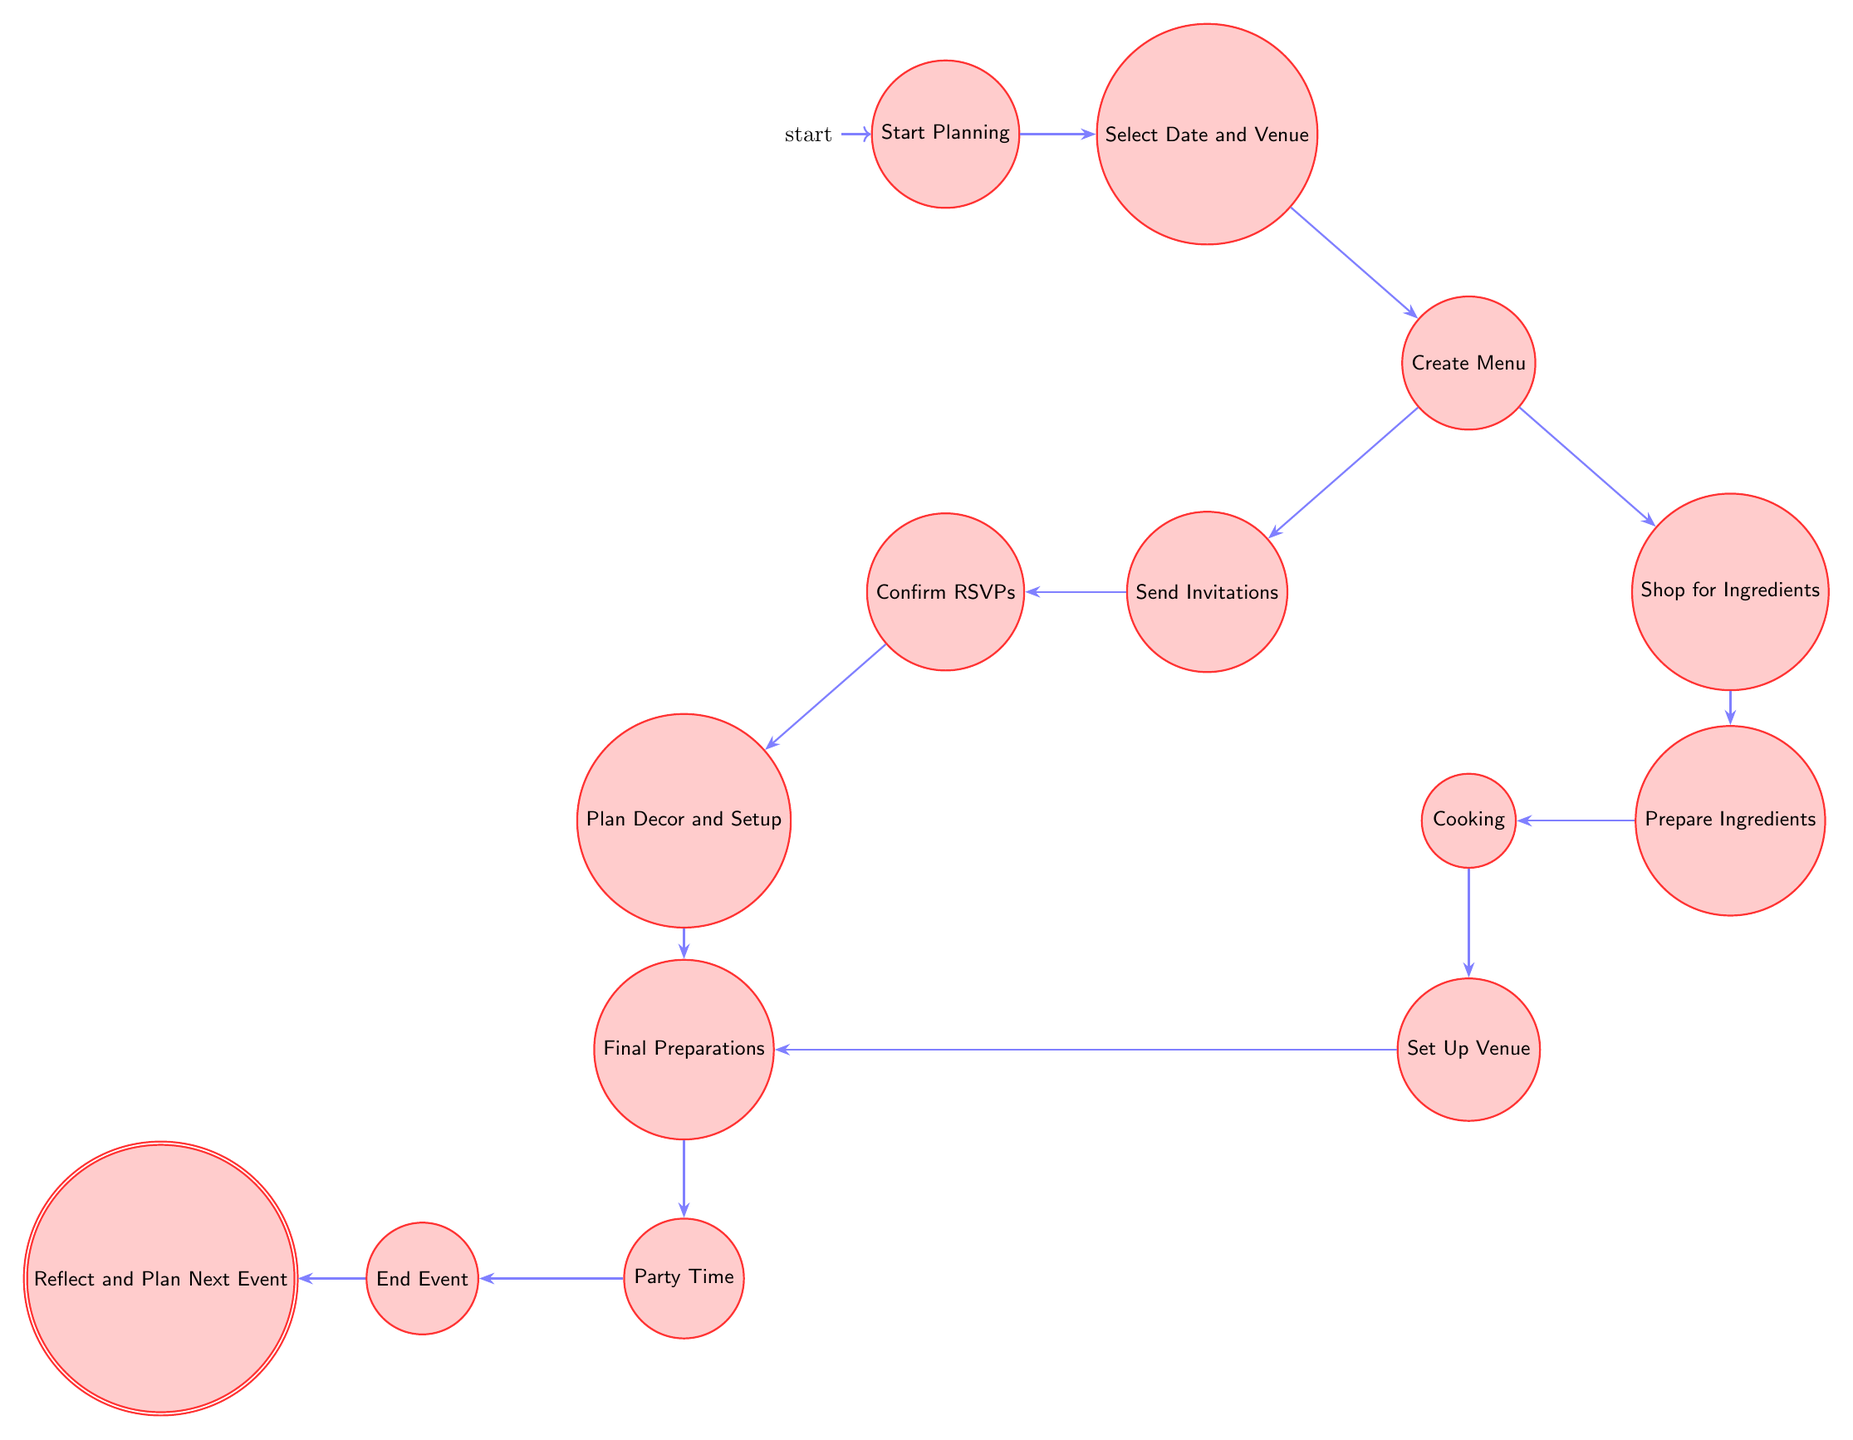What is the first state in the diagram? The first state is labeled as "Start Planning", indicating the initial step in planning the dinner party.
Answer: Start Planning How many states are there in total? By counting all the labeled states in the diagram, we find a total of 14 states, each representing a specific stage in the planning process.
Answer: 14 Which state follows "Send Invitations"? The state that follows "Send Invitations" is "Confirm RSVPs", representing the next step where responses from the invitations are tracked.
Answer: Confirm RSVPs What are the two possible transitions from "Create Menu"? The two transitions from "Create Menu" lead to "Send Invitations" and "Shop for Ingredients", showcasing the paths available after the menu is created.
Answer: Send Invitations and Shop for Ingredients What actions are associated with the "Party Time" state? The actions associated with "Party Time" include "Welcome Guests", "Serve Dishes", and "Enjoy the Evening", detailing the activities during the event itself.
Answer: Welcome Guests, Serve Dishes, Enjoy the Evening What is the last state before "Reflect and Plan Next Event"? The last state before "Reflect and Plan Next Event" is "End Event," as it signifies the conclusion of the dinner party proceedings.
Answer: End Event What does the state "Prepare Ingredients" lead to? The state "Prepare Ingredients" leads to the "Cooking" state, demonstrating that once the ingredients are prepared, the next step is cooking.
Answer: Cooking Which actions take place in the state "Final Preparations"? In the "Final Preparations" state, the actions include "Review Checklist" and "Make Final Adjustments" to ensure everything is ready for the party.
Answer: Review Checklist, Make Final Adjustments What is the relationship between "Shop for Ingredients" and "Prepare Ingredients"? "Shop for Ingredients" precedes "Prepare Ingredients", showing that shopping is necessary before the ingredients can be prepared for cooking.
Answer: Precedes What state comes directly after "Cooking"? The state that comes directly after "Cooking" is "Set Up Venue", indicating that once cooking is done, the next step is setting up the venue for the dinner party.
Answer: Set Up Venue 